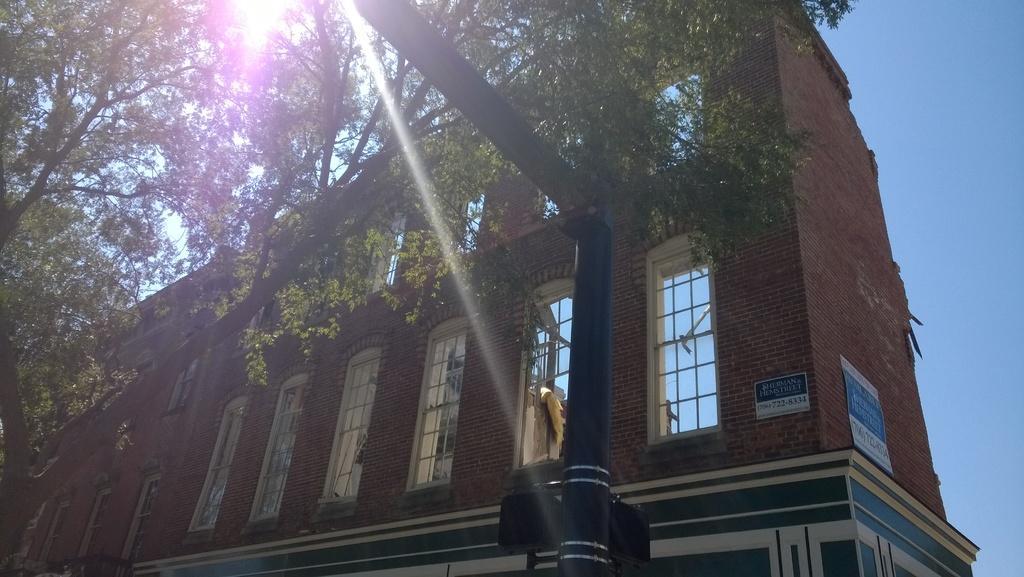Please provide a concise description of this image. In the center of the image we can see the sky, one building, windows, one tree with branches and leaves, posters with some text, one pole and a few other objects. 